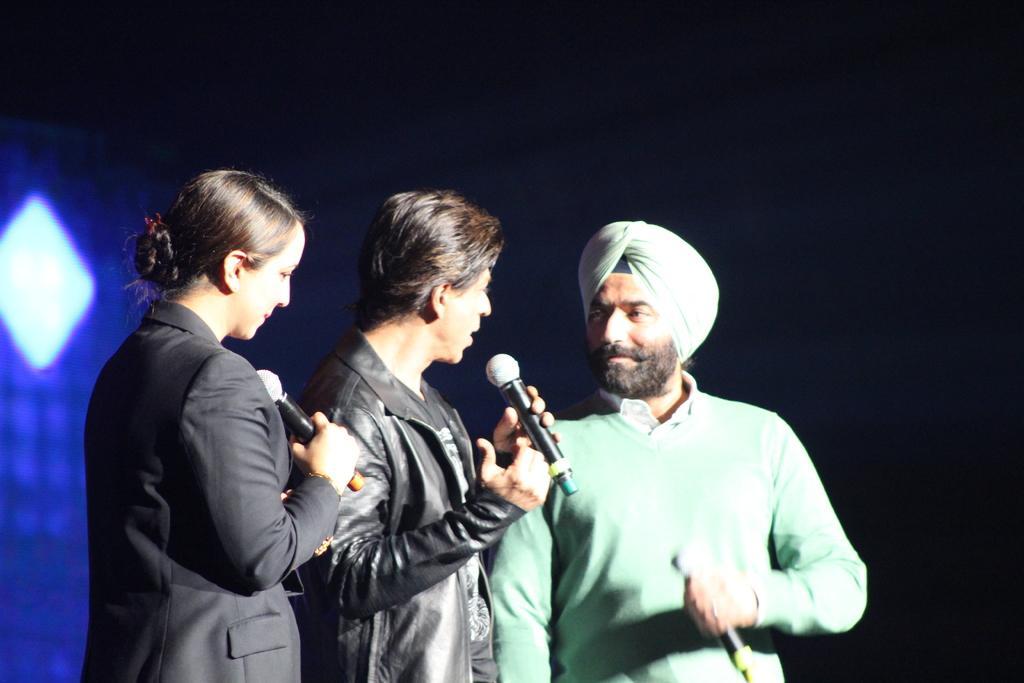Could you give a brief overview of what you see in this image? In this picture there are three people who are standing and holding a mic in their hand. There is a light at the background. 